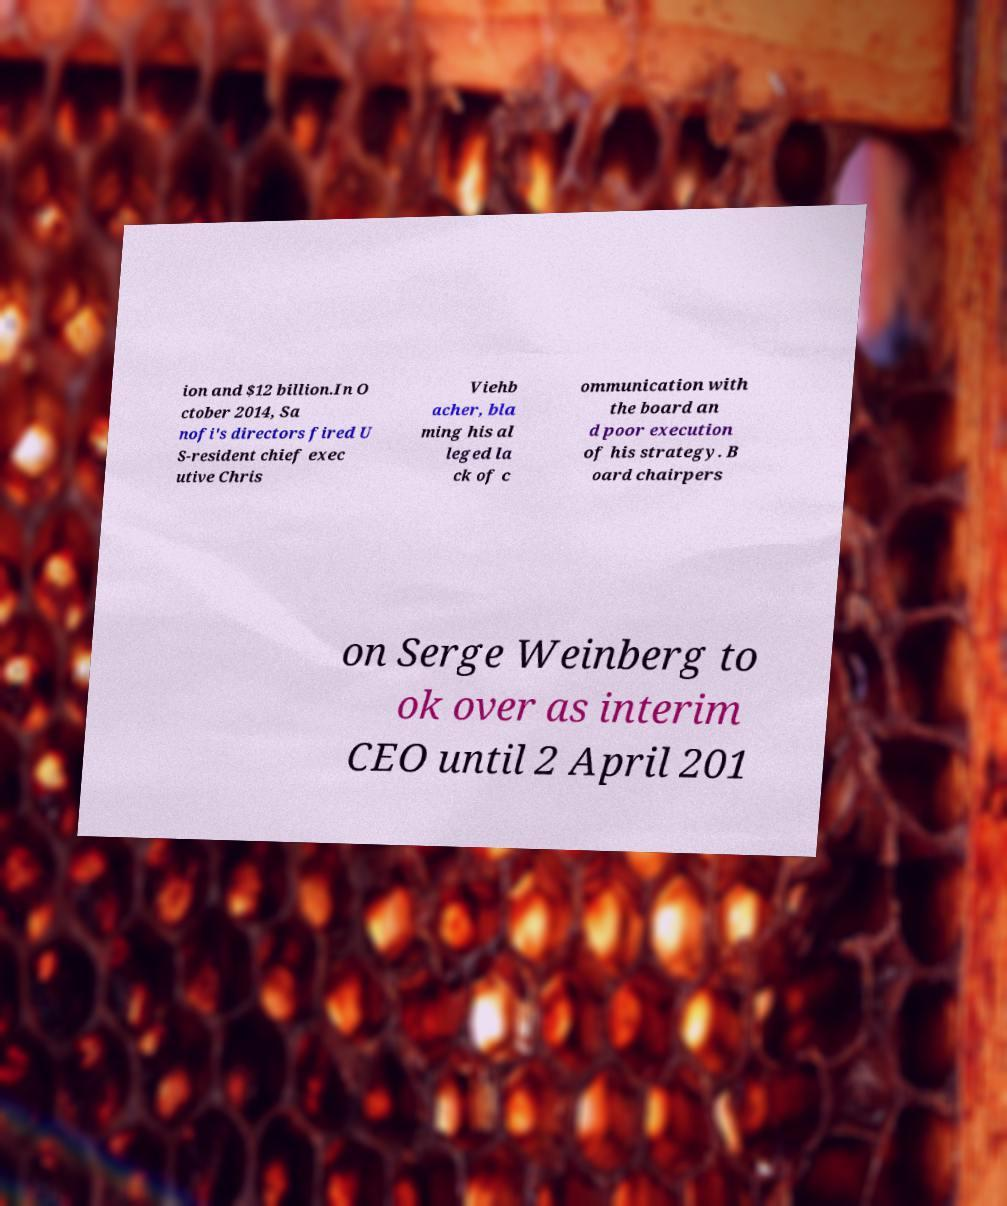Can you accurately transcribe the text from the provided image for me? ion and $12 billion.In O ctober 2014, Sa nofi's directors fired U S-resident chief exec utive Chris Viehb acher, bla ming his al leged la ck of c ommunication with the board an d poor execution of his strategy. B oard chairpers on Serge Weinberg to ok over as interim CEO until 2 April 201 